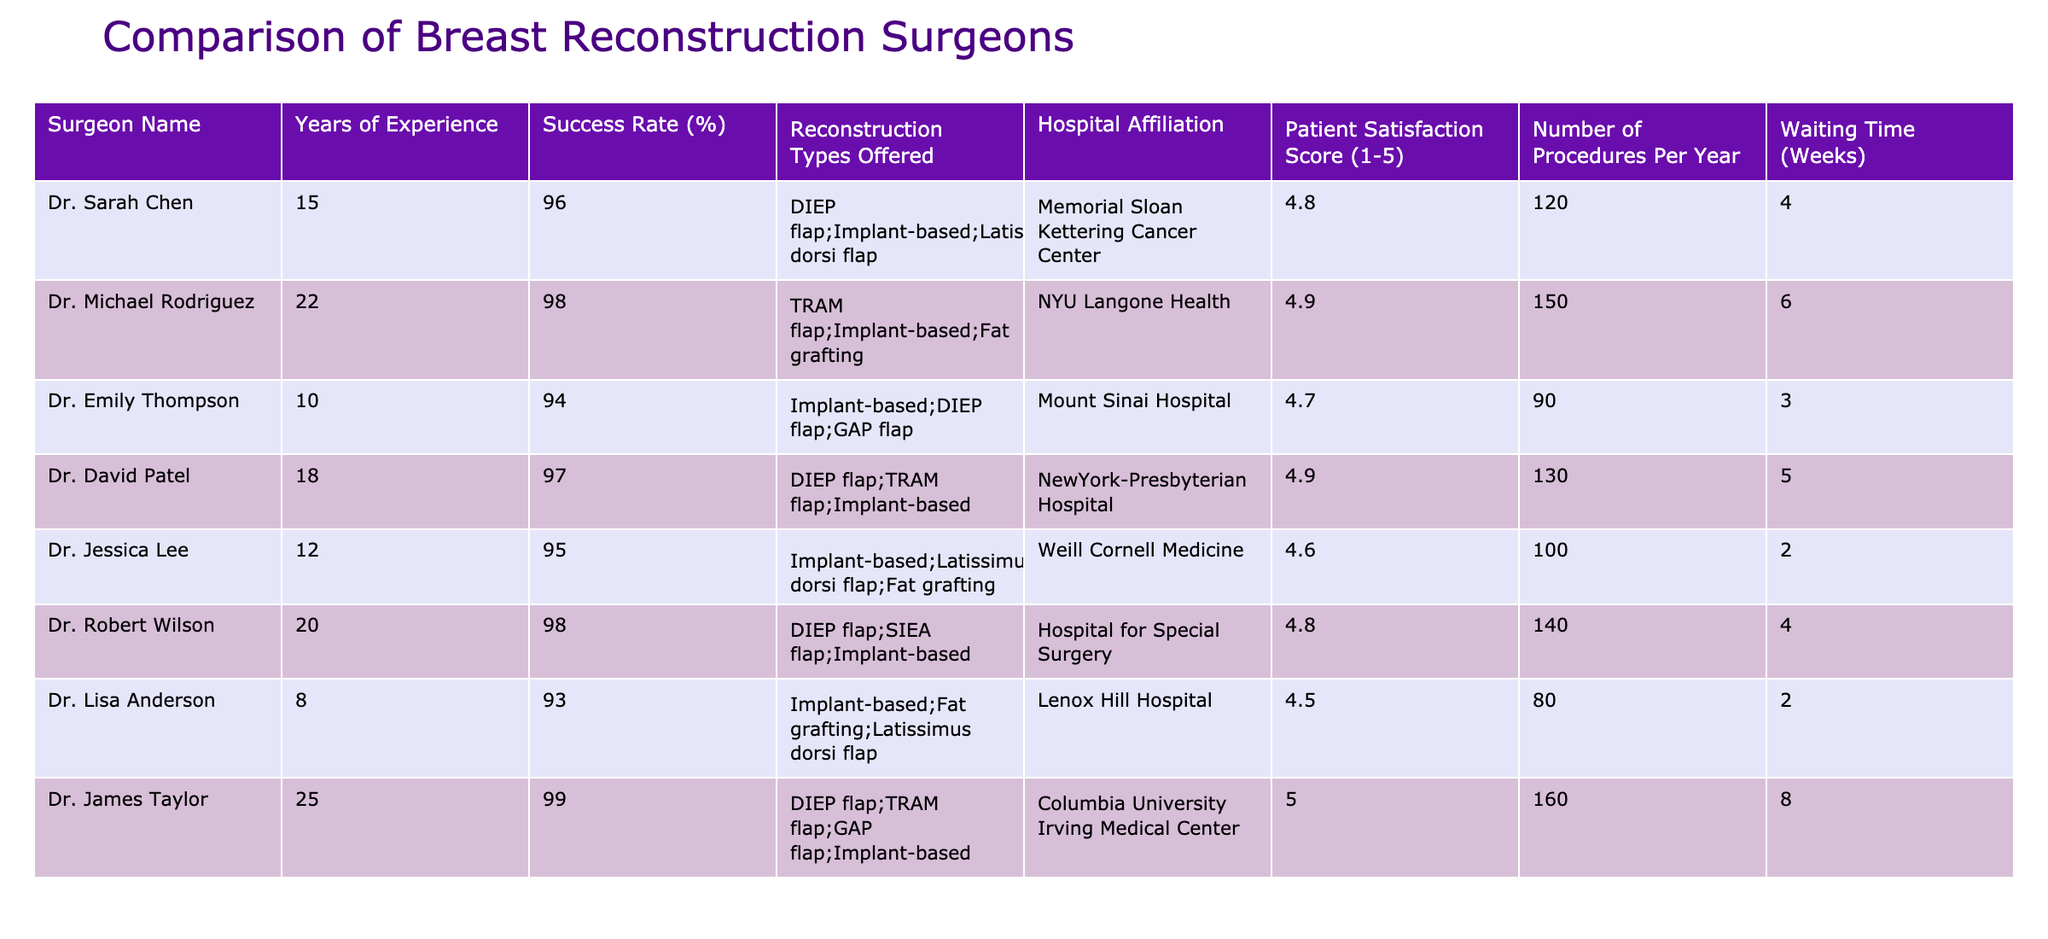What is Dr. James Taylor's success rate? According to the table, Dr. James Taylor has a success rate of 99%.
Answer: 99% Which surgeon has the highest patient satisfaction score? From the table, Dr. James Taylor has the highest patient satisfaction score of 5.0.
Answer: 5.0 What is the average success rate of the surgeons listed? To find the average success rate, add all individual success rates (96 + 98 + 94 + 97 + 95 + 98 + 93 + 99) = 775. Then divide by the number of surgeons (8), resulting in an average success rate of 775/8 = 96.875%.
Answer: 96.88% Does Dr. Lisa Anderson have a success rate above 90%? Yes, Dr. Lisa Anderson has a success rate of 93%, which is above 90%.
Answer: Yes Which surgeon has the longest waiting time? The table indicates that Dr. James Taylor has the longest waiting time of 8 weeks.
Answer: 8 weeks How many procedures does Dr. Michael Rodriguez perform per year compared to Dr. Sarah Chen? Dr. Michael Rodriguez performs 150 procedures per year and Dr. Sarah Chen performs 120. The difference is 150 - 120 = 30 procedures.
Answer: 30 procedures Is there any surgeon affiliated with Memorial Sloan Kettering Cancer Center who has a success rate of 95% or lower? Yes, Dr. Emily Thompson, who is affiliated with Mount Sinai Hospital, has a success rate of 94%.
Answer: No What type of reconstruction does Dr. Robert Wilson offer, and how does it compare to Dr. Jessica Lee? Dr. Robert Wilson offers DIEP flap, SIEA flap, and implant-based reconstruction, whereas Dr. Jessica Lee offers implant-based, latissimus dorsi flap, and fat grafting. Both offer implant-based options, but the types differ.
Answer: Different types offered 